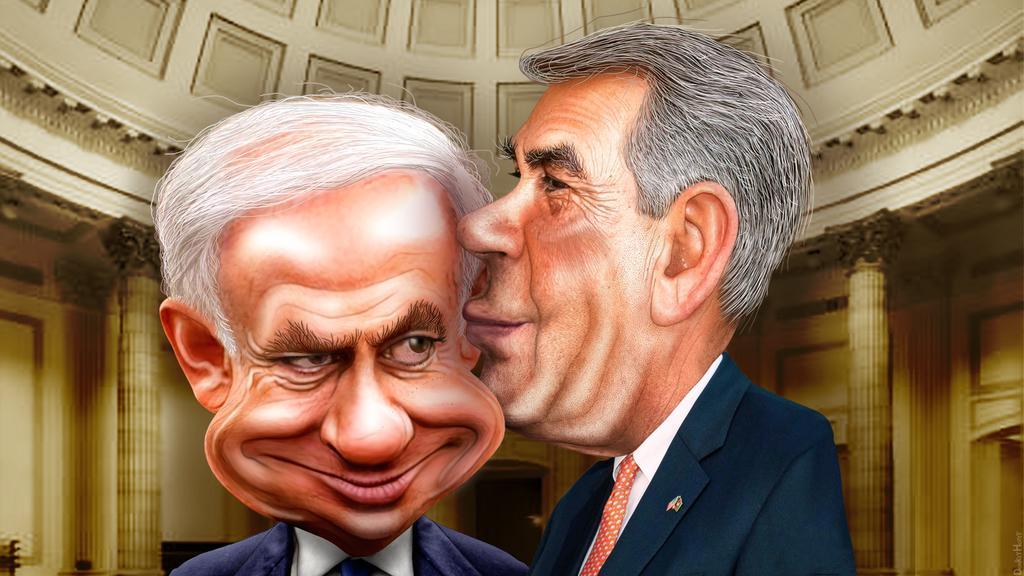In one or two sentences, can you explain what this image depicts? This is a cartoon picture. This picture is an inside view of a building. In the center of the image we can see two mens are standing and wearing suits. In the background of the image we can see the pillars, wall, door, chair. At the top of the image we can see the roof. 